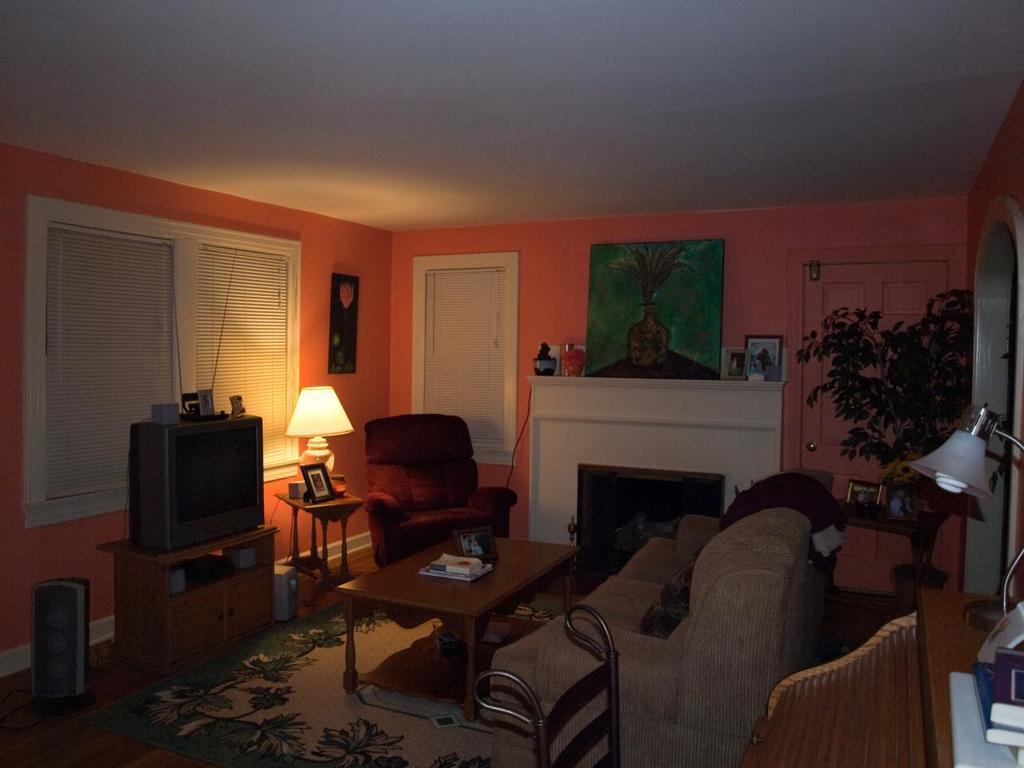In one or two sentences, can you explain what this image depicts? This image is clicked in a room. To the right, there is a sofa. In the middle, there is a table on which books are kept. To the left, there is a TV. In the background, there is a wall to which windows and doors are fixed. To the right, there is a plant. At the bottom, there is a floor mat on the floor. 